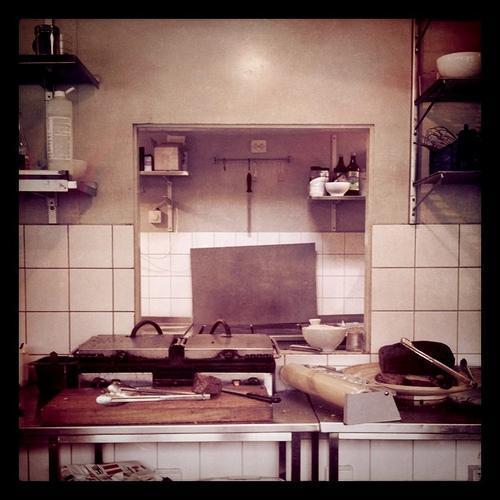How many pairs of tongs are there?
Give a very brief answer. 1. 